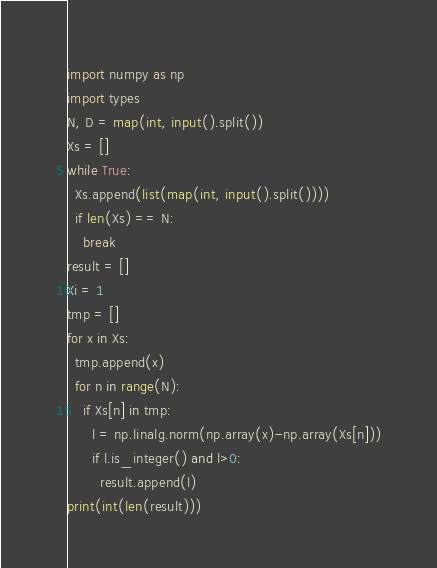<code> <loc_0><loc_0><loc_500><loc_500><_Python_>import numpy as np
import types
N, D = map(int, input().split())
Xs = []
while True:
  Xs.append(list(map(int, input().split())))
  if len(Xs) == N:
    break
result = []
Xi = 1
tmp = []
for x in Xs:
  tmp.append(x)
  for n in range(N):
    if Xs[n] in tmp:
      l = np.linalg.norm(np.array(x)-np.array(Xs[n]))
      if l.is_integer() and l>0:
        result.append(l)
print(int(len(result)))
</code> 